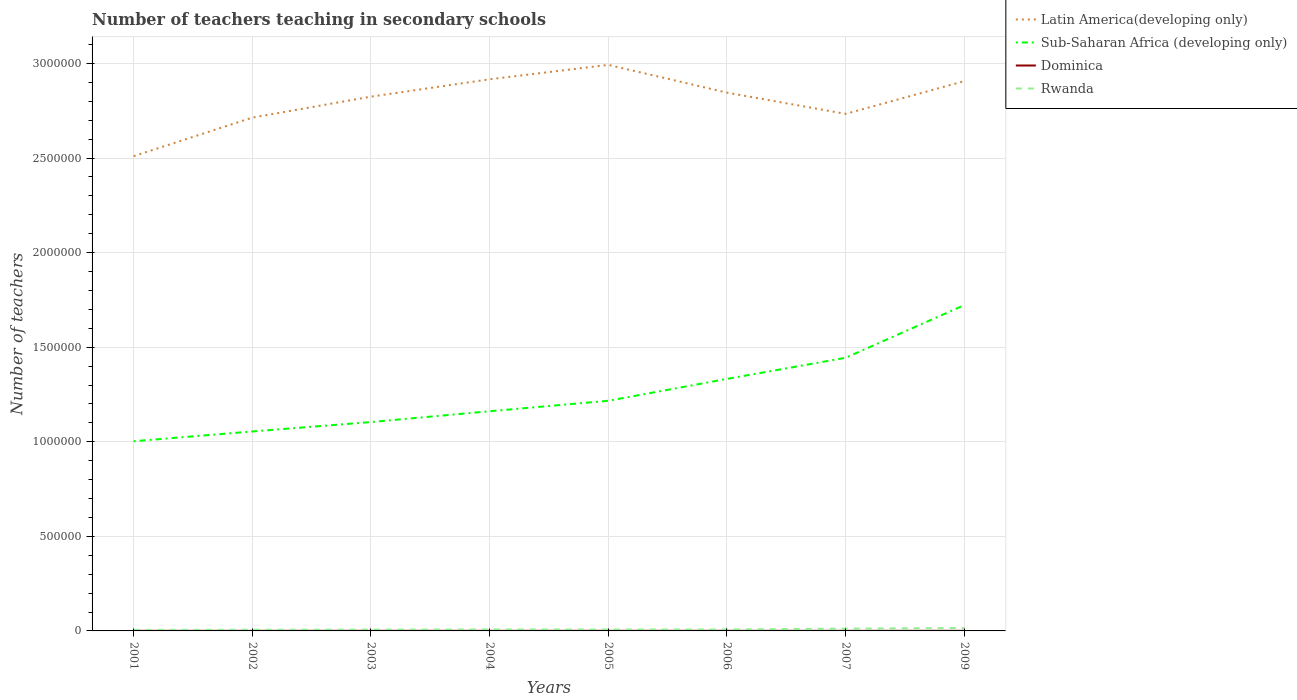How many different coloured lines are there?
Your response must be concise. 4. Does the line corresponding to Dominica intersect with the line corresponding to Latin America(developing only)?
Provide a succinct answer. No. Across all years, what is the maximum number of teachers teaching in secondary schools in Latin America(developing only)?
Your answer should be compact. 2.51e+06. What is the total number of teachers teaching in secondary schools in Rwanda in the graph?
Give a very brief answer. -760. What is the difference between the highest and the second highest number of teachers teaching in secondary schools in Rwanda?
Your response must be concise. 9876. Is the number of teachers teaching in secondary schools in Rwanda strictly greater than the number of teachers teaching in secondary schools in Dominica over the years?
Offer a very short reply. No. How many years are there in the graph?
Your answer should be very brief. 8. Where does the legend appear in the graph?
Your answer should be compact. Top right. How many legend labels are there?
Offer a very short reply. 4. How are the legend labels stacked?
Your response must be concise. Vertical. What is the title of the graph?
Ensure brevity in your answer.  Number of teachers teaching in secondary schools. Does "Macao" appear as one of the legend labels in the graph?
Make the answer very short. No. What is the label or title of the Y-axis?
Your response must be concise. Number of teachers. What is the Number of teachers of Latin America(developing only) in 2001?
Your answer should be very brief. 2.51e+06. What is the Number of teachers in Sub-Saharan Africa (developing only) in 2001?
Make the answer very short. 1.00e+06. What is the Number of teachers of Dominica in 2001?
Make the answer very short. 374. What is the Number of teachers of Rwanda in 2001?
Provide a succinct answer. 5453. What is the Number of teachers in Latin America(developing only) in 2002?
Keep it short and to the point. 2.71e+06. What is the Number of teachers in Sub-Saharan Africa (developing only) in 2002?
Your answer should be compact. 1.05e+06. What is the Number of teachers in Dominica in 2002?
Ensure brevity in your answer.  443. What is the Number of teachers of Rwanda in 2002?
Make the answer very short. 6329. What is the Number of teachers of Latin America(developing only) in 2003?
Your answer should be very brief. 2.82e+06. What is the Number of teachers in Sub-Saharan Africa (developing only) in 2003?
Your response must be concise. 1.10e+06. What is the Number of teachers in Dominica in 2003?
Make the answer very short. 460. What is the Number of teachers in Rwanda in 2003?
Ensure brevity in your answer.  7058. What is the Number of teachers in Latin America(developing only) in 2004?
Provide a succinct answer. 2.92e+06. What is the Number of teachers in Sub-Saharan Africa (developing only) in 2004?
Ensure brevity in your answer.  1.16e+06. What is the Number of teachers of Dominica in 2004?
Give a very brief answer. 445. What is the Number of teachers of Rwanda in 2004?
Ensure brevity in your answer.  7750. What is the Number of teachers of Latin America(developing only) in 2005?
Keep it short and to the point. 2.99e+06. What is the Number of teachers of Sub-Saharan Africa (developing only) in 2005?
Keep it short and to the point. 1.22e+06. What is the Number of teachers in Dominica in 2005?
Make the answer very short. 496. What is the Number of teachers in Rwanda in 2005?
Make the answer very short. 7610. What is the Number of teachers in Latin America(developing only) in 2006?
Your answer should be compact. 2.85e+06. What is the Number of teachers in Sub-Saharan Africa (developing only) in 2006?
Keep it short and to the point. 1.33e+06. What is the Number of teachers of Dominica in 2006?
Your response must be concise. 455. What is the Number of teachers of Rwanda in 2006?
Keep it short and to the point. 7818. What is the Number of teachers of Latin America(developing only) in 2007?
Ensure brevity in your answer.  2.73e+06. What is the Number of teachers in Sub-Saharan Africa (developing only) in 2007?
Ensure brevity in your answer.  1.44e+06. What is the Number of teachers of Dominica in 2007?
Provide a short and direct response. 469. What is the Number of teachers of Rwanda in 2007?
Provide a short and direct response. 1.21e+04. What is the Number of teachers in Latin America(developing only) in 2009?
Give a very brief answer. 2.91e+06. What is the Number of teachers in Sub-Saharan Africa (developing only) in 2009?
Your response must be concise. 1.72e+06. What is the Number of teachers of Dominica in 2009?
Offer a terse response. 524. What is the Number of teachers of Rwanda in 2009?
Ensure brevity in your answer.  1.53e+04. Across all years, what is the maximum Number of teachers in Latin America(developing only)?
Offer a terse response. 2.99e+06. Across all years, what is the maximum Number of teachers in Sub-Saharan Africa (developing only)?
Make the answer very short. 1.72e+06. Across all years, what is the maximum Number of teachers of Dominica?
Your answer should be compact. 524. Across all years, what is the maximum Number of teachers in Rwanda?
Keep it short and to the point. 1.53e+04. Across all years, what is the minimum Number of teachers of Latin America(developing only)?
Offer a very short reply. 2.51e+06. Across all years, what is the minimum Number of teachers of Sub-Saharan Africa (developing only)?
Keep it short and to the point. 1.00e+06. Across all years, what is the minimum Number of teachers in Dominica?
Offer a very short reply. 374. Across all years, what is the minimum Number of teachers in Rwanda?
Make the answer very short. 5453. What is the total Number of teachers of Latin America(developing only) in the graph?
Provide a short and direct response. 2.24e+07. What is the total Number of teachers of Sub-Saharan Africa (developing only) in the graph?
Give a very brief answer. 1.00e+07. What is the total Number of teachers in Dominica in the graph?
Your answer should be compact. 3666. What is the total Number of teachers in Rwanda in the graph?
Your answer should be very brief. 6.94e+04. What is the difference between the Number of teachers in Latin America(developing only) in 2001 and that in 2002?
Your response must be concise. -2.04e+05. What is the difference between the Number of teachers of Sub-Saharan Africa (developing only) in 2001 and that in 2002?
Your answer should be very brief. -5.16e+04. What is the difference between the Number of teachers of Dominica in 2001 and that in 2002?
Offer a very short reply. -69. What is the difference between the Number of teachers in Rwanda in 2001 and that in 2002?
Provide a succinct answer. -876. What is the difference between the Number of teachers of Latin America(developing only) in 2001 and that in 2003?
Provide a succinct answer. -3.15e+05. What is the difference between the Number of teachers in Sub-Saharan Africa (developing only) in 2001 and that in 2003?
Keep it short and to the point. -1.01e+05. What is the difference between the Number of teachers of Dominica in 2001 and that in 2003?
Make the answer very short. -86. What is the difference between the Number of teachers of Rwanda in 2001 and that in 2003?
Keep it short and to the point. -1605. What is the difference between the Number of teachers of Latin America(developing only) in 2001 and that in 2004?
Your answer should be compact. -4.06e+05. What is the difference between the Number of teachers of Sub-Saharan Africa (developing only) in 2001 and that in 2004?
Give a very brief answer. -1.59e+05. What is the difference between the Number of teachers in Dominica in 2001 and that in 2004?
Ensure brevity in your answer.  -71. What is the difference between the Number of teachers of Rwanda in 2001 and that in 2004?
Your answer should be very brief. -2297. What is the difference between the Number of teachers in Latin America(developing only) in 2001 and that in 2005?
Offer a very short reply. -4.83e+05. What is the difference between the Number of teachers of Sub-Saharan Africa (developing only) in 2001 and that in 2005?
Give a very brief answer. -2.14e+05. What is the difference between the Number of teachers in Dominica in 2001 and that in 2005?
Offer a very short reply. -122. What is the difference between the Number of teachers of Rwanda in 2001 and that in 2005?
Provide a short and direct response. -2157. What is the difference between the Number of teachers in Latin America(developing only) in 2001 and that in 2006?
Keep it short and to the point. -3.36e+05. What is the difference between the Number of teachers of Sub-Saharan Africa (developing only) in 2001 and that in 2006?
Offer a terse response. -3.30e+05. What is the difference between the Number of teachers of Dominica in 2001 and that in 2006?
Give a very brief answer. -81. What is the difference between the Number of teachers in Rwanda in 2001 and that in 2006?
Provide a succinct answer. -2365. What is the difference between the Number of teachers of Latin America(developing only) in 2001 and that in 2007?
Give a very brief answer. -2.24e+05. What is the difference between the Number of teachers of Sub-Saharan Africa (developing only) in 2001 and that in 2007?
Your answer should be compact. -4.41e+05. What is the difference between the Number of teachers of Dominica in 2001 and that in 2007?
Offer a terse response. -95. What is the difference between the Number of teachers in Rwanda in 2001 and that in 2007?
Ensure brevity in your answer.  -6650. What is the difference between the Number of teachers in Latin America(developing only) in 2001 and that in 2009?
Provide a short and direct response. -3.96e+05. What is the difference between the Number of teachers in Sub-Saharan Africa (developing only) in 2001 and that in 2009?
Provide a succinct answer. -7.20e+05. What is the difference between the Number of teachers of Dominica in 2001 and that in 2009?
Offer a very short reply. -150. What is the difference between the Number of teachers in Rwanda in 2001 and that in 2009?
Offer a very short reply. -9876. What is the difference between the Number of teachers of Latin America(developing only) in 2002 and that in 2003?
Your answer should be compact. -1.11e+05. What is the difference between the Number of teachers of Sub-Saharan Africa (developing only) in 2002 and that in 2003?
Offer a terse response. -4.98e+04. What is the difference between the Number of teachers of Dominica in 2002 and that in 2003?
Your answer should be compact. -17. What is the difference between the Number of teachers in Rwanda in 2002 and that in 2003?
Offer a very short reply. -729. What is the difference between the Number of teachers in Latin America(developing only) in 2002 and that in 2004?
Ensure brevity in your answer.  -2.03e+05. What is the difference between the Number of teachers of Sub-Saharan Africa (developing only) in 2002 and that in 2004?
Make the answer very short. -1.07e+05. What is the difference between the Number of teachers in Dominica in 2002 and that in 2004?
Offer a very short reply. -2. What is the difference between the Number of teachers in Rwanda in 2002 and that in 2004?
Offer a terse response. -1421. What is the difference between the Number of teachers in Latin America(developing only) in 2002 and that in 2005?
Ensure brevity in your answer.  -2.79e+05. What is the difference between the Number of teachers of Sub-Saharan Africa (developing only) in 2002 and that in 2005?
Your answer should be very brief. -1.62e+05. What is the difference between the Number of teachers in Dominica in 2002 and that in 2005?
Your answer should be very brief. -53. What is the difference between the Number of teachers in Rwanda in 2002 and that in 2005?
Give a very brief answer. -1281. What is the difference between the Number of teachers in Latin America(developing only) in 2002 and that in 2006?
Offer a very short reply. -1.32e+05. What is the difference between the Number of teachers in Sub-Saharan Africa (developing only) in 2002 and that in 2006?
Provide a succinct answer. -2.78e+05. What is the difference between the Number of teachers in Rwanda in 2002 and that in 2006?
Your response must be concise. -1489. What is the difference between the Number of teachers in Latin America(developing only) in 2002 and that in 2007?
Provide a succinct answer. -1.98e+04. What is the difference between the Number of teachers in Sub-Saharan Africa (developing only) in 2002 and that in 2007?
Offer a very short reply. -3.90e+05. What is the difference between the Number of teachers of Dominica in 2002 and that in 2007?
Offer a very short reply. -26. What is the difference between the Number of teachers of Rwanda in 2002 and that in 2007?
Your answer should be very brief. -5774. What is the difference between the Number of teachers of Latin America(developing only) in 2002 and that in 2009?
Provide a succinct answer. -1.93e+05. What is the difference between the Number of teachers of Sub-Saharan Africa (developing only) in 2002 and that in 2009?
Make the answer very short. -6.68e+05. What is the difference between the Number of teachers in Dominica in 2002 and that in 2009?
Keep it short and to the point. -81. What is the difference between the Number of teachers in Rwanda in 2002 and that in 2009?
Keep it short and to the point. -9000. What is the difference between the Number of teachers of Latin America(developing only) in 2003 and that in 2004?
Your response must be concise. -9.17e+04. What is the difference between the Number of teachers in Sub-Saharan Africa (developing only) in 2003 and that in 2004?
Your answer should be compact. -5.71e+04. What is the difference between the Number of teachers in Dominica in 2003 and that in 2004?
Provide a succinct answer. 15. What is the difference between the Number of teachers in Rwanda in 2003 and that in 2004?
Give a very brief answer. -692. What is the difference between the Number of teachers in Latin America(developing only) in 2003 and that in 2005?
Your response must be concise. -1.68e+05. What is the difference between the Number of teachers of Sub-Saharan Africa (developing only) in 2003 and that in 2005?
Offer a terse response. -1.12e+05. What is the difference between the Number of teachers in Dominica in 2003 and that in 2005?
Your response must be concise. -36. What is the difference between the Number of teachers of Rwanda in 2003 and that in 2005?
Provide a short and direct response. -552. What is the difference between the Number of teachers of Latin America(developing only) in 2003 and that in 2006?
Your answer should be compact. -2.10e+04. What is the difference between the Number of teachers of Sub-Saharan Africa (developing only) in 2003 and that in 2006?
Offer a very short reply. -2.28e+05. What is the difference between the Number of teachers of Dominica in 2003 and that in 2006?
Make the answer very short. 5. What is the difference between the Number of teachers of Rwanda in 2003 and that in 2006?
Your answer should be very brief. -760. What is the difference between the Number of teachers of Latin America(developing only) in 2003 and that in 2007?
Your response must be concise. 9.12e+04. What is the difference between the Number of teachers in Sub-Saharan Africa (developing only) in 2003 and that in 2007?
Provide a succinct answer. -3.40e+05. What is the difference between the Number of teachers of Rwanda in 2003 and that in 2007?
Keep it short and to the point. -5045. What is the difference between the Number of teachers of Latin America(developing only) in 2003 and that in 2009?
Ensure brevity in your answer.  -8.18e+04. What is the difference between the Number of teachers of Sub-Saharan Africa (developing only) in 2003 and that in 2009?
Keep it short and to the point. -6.18e+05. What is the difference between the Number of teachers of Dominica in 2003 and that in 2009?
Your response must be concise. -64. What is the difference between the Number of teachers of Rwanda in 2003 and that in 2009?
Your response must be concise. -8271. What is the difference between the Number of teachers of Latin America(developing only) in 2004 and that in 2005?
Make the answer very short. -7.62e+04. What is the difference between the Number of teachers of Sub-Saharan Africa (developing only) in 2004 and that in 2005?
Offer a terse response. -5.53e+04. What is the difference between the Number of teachers of Dominica in 2004 and that in 2005?
Make the answer very short. -51. What is the difference between the Number of teachers of Rwanda in 2004 and that in 2005?
Ensure brevity in your answer.  140. What is the difference between the Number of teachers in Latin America(developing only) in 2004 and that in 2006?
Your answer should be compact. 7.07e+04. What is the difference between the Number of teachers in Sub-Saharan Africa (developing only) in 2004 and that in 2006?
Your answer should be compact. -1.71e+05. What is the difference between the Number of teachers in Rwanda in 2004 and that in 2006?
Provide a succinct answer. -68. What is the difference between the Number of teachers in Latin America(developing only) in 2004 and that in 2007?
Offer a terse response. 1.83e+05. What is the difference between the Number of teachers in Sub-Saharan Africa (developing only) in 2004 and that in 2007?
Offer a very short reply. -2.83e+05. What is the difference between the Number of teachers in Rwanda in 2004 and that in 2007?
Your answer should be compact. -4353. What is the difference between the Number of teachers of Latin America(developing only) in 2004 and that in 2009?
Your answer should be compact. 9897.5. What is the difference between the Number of teachers of Sub-Saharan Africa (developing only) in 2004 and that in 2009?
Make the answer very short. -5.61e+05. What is the difference between the Number of teachers in Dominica in 2004 and that in 2009?
Keep it short and to the point. -79. What is the difference between the Number of teachers in Rwanda in 2004 and that in 2009?
Ensure brevity in your answer.  -7579. What is the difference between the Number of teachers in Latin America(developing only) in 2005 and that in 2006?
Your response must be concise. 1.47e+05. What is the difference between the Number of teachers of Sub-Saharan Africa (developing only) in 2005 and that in 2006?
Your answer should be compact. -1.16e+05. What is the difference between the Number of teachers in Dominica in 2005 and that in 2006?
Offer a very short reply. 41. What is the difference between the Number of teachers in Rwanda in 2005 and that in 2006?
Provide a succinct answer. -208. What is the difference between the Number of teachers of Latin America(developing only) in 2005 and that in 2007?
Give a very brief answer. 2.59e+05. What is the difference between the Number of teachers in Sub-Saharan Africa (developing only) in 2005 and that in 2007?
Give a very brief answer. -2.27e+05. What is the difference between the Number of teachers of Dominica in 2005 and that in 2007?
Keep it short and to the point. 27. What is the difference between the Number of teachers of Rwanda in 2005 and that in 2007?
Provide a succinct answer. -4493. What is the difference between the Number of teachers in Latin America(developing only) in 2005 and that in 2009?
Your answer should be compact. 8.61e+04. What is the difference between the Number of teachers of Sub-Saharan Africa (developing only) in 2005 and that in 2009?
Your answer should be very brief. -5.06e+05. What is the difference between the Number of teachers in Dominica in 2005 and that in 2009?
Provide a succinct answer. -28. What is the difference between the Number of teachers in Rwanda in 2005 and that in 2009?
Offer a very short reply. -7719. What is the difference between the Number of teachers in Latin America(developing only) in 2006 and that in 2007?
Your answer should be very brief. 1.12e+05. What is the difference between the Number of teachers in Sub-Saharan Africa (developing only) in 2006 and that in 2007?
Offer a terse response. -1.12e+05. What is the difference between the Number of teachers in Dominica in 2006 and that in 2007?
Offer a terse response. -14. What is the difference between the Number of teachers of Rwanda in 2006 and that in 2007?
Provide a short and direct response. -4285. What is the difference between the Number of teachers of Latin America(developing only) in 2006 and that in 2009?
Your answer should be very brief. -6.08e+04. What is the difference between the Number of teachers in Sub-Saharan Africa (developing only) in 2006 and that in 2009?
Your response must be concise. -3.90e+05. What is the difference between the Number of teachers in Dominica in 2006 and that in 2009?
Provide a short and direct response. -69. What is the difference between the Number of teachers of Rwanda in 2006 and that in 2009?
Make the answer very short. -7511. What is the difference between the Number of teachers of Latin America(developing only) in 2007 and that in 2009?
Your answer should be compact. -1.73e+05. What is the difference between the Number of teachers in Sub-Saharan Africa (developing only) in 2007 and that in 2009?
Your answer should be compact. -2.78e+05. What is the difference between the Number of teachers in Dominica in 2007 and that in 2009?
Provide a short and direct response. -55. What is the difference between the Number of teachers of Rwanda in 2007 and that in 2009?
Offer a very short reply. -3226. What is the difference between the Number of teachers in Latin America(developing only) in 2001 and the Number of teachers in Sub-Saharan Africa (developing only) in 2002?
Your answer should be compact. 1.46e+06. What is the difference between the Number of teachers of Latin America(developing only) in 2001 and the Number of teachers of Dominica in 2002?
Provide a short and direct response. 2.51e+06. What is the difference between the Number of teachers of Latin America(developing only) in 2001 and the Number of teachers of Rwanda in 2002?
Provide a short and direct response. 2.50e+06. What is the difference between the Number of teachers in Sub-Saharan Africa (developing only) in 2001 and the Number of teachers in Dominica in 2002?
Provide a short and direct response. 1.00e+06. What is the difference between the Number of teachers in Sub-Saharan Africa (developing only) in 2001 and the Number of teachers in Rwanda in 2002?
Keep it short and to the point. 9.97e+05. What is the difference between the Number of teachers of Dominica in 2001 and the Number of teachers of Rwanda in 2002?
Make the answer very short. -5955. What is the difference between the Number of teachers in Latin America(developing only) in 2001 and the Number of teachers in Sub-Saharan Africa (developing only) in 2003?
Make the answer very short. 1.41e+06. What is the difference between the Number of teachers of Latin America(developing only) in 2001 and the Number of teachers of Dominica in 2003?
Your response must be concise. 2.51e+06. What is the difference between the Number of teachers in Latin America(developing only) in 2001 and the Number of teachers in Rwanda in 2003?
Your answer should be compact. 2.50e+06. What is the difference between the Number of teachers of Sub-Saharan Africa (developing only) in 2001 and the Number of teachers of Dominica in 2003?
Ensure brevity in your answer.  1.00e+06. What is the difference between the Number of teachers of Sub-Saharan Africa (developing only) in 2001 and the Number of teachers of Rwanda in 2003?
Offer a very short reply. 9.96e+05. What is the difference between the Number of teachers in Dominica in 2001 and the Number of teachers in Rwanda in 2003?
Offer a very short reply. -6684. What is the difference between the Number of teachers of Latin America(developing only) in 2001 and the Number of teachers of Sub-Saharan Africa (developing only) in 2004?
Make the answer very short. 1.35e+06. What is the difference between the Number of teachers of Latin America(developing only) in 2001 and the Number of teachers of Dominica in 2004?
Offer a very short reply. 2.51e+06. What is the difference between the Number of teachers of Latin America(developing only) in 2001 and the Number of teachers of Rwanda in 2004?
Make the answer very short. 2.50e+06. What is the difference between the Number of teachers in Sub-Saharan Africa (developing only) in 2001 and the Number of teachers in Dominica in 2004?
Keep it short and to the point. 1.00e+06. What is the difference between the Number of teachers of Sub-Saharan Africa (developing only) in 2001 and the Number of teachers of Rwanda in 2004?
Ensure brevity in your answer.  9.95e+05. What is the difference between the Number of teachers of Dominica in 2001 and the Number of teachers of Rwanda in 2004?
Ensure brevity in your answer.  -7376. What is the difference between the Number of teachers in Latin America(developing only) in 2001 and the Number of teachers in Sub-Saharan Africa (developing only) in 2005?
Your answer should be very brief. 1.29e+06. What is the difference between the Number of teachers in Latin America(developing only) in 2001 and the Number of teachers in Dominica in 2005?
Your answer should be very brief. 2.51e+06. What is the difference between the Number of teachers of Latin America(developing only) in 2001 and the Number of teachers of Rwanda in 2005?
Offer a very short reply. 2.50e+06. What is the difference between the Number of teachers of Sub-Saharan Africa (developing only) in 2001 and the Number of teachers of Dominica in 2005?
Provide a short and direct response. 1.00e+06. What is the difference between the Number of teachers in Sub-Saharan Africa (developing only) in 2001 and the Number of teachers in Rwanda in 2005?
Offer a terse response. 9.95e+05. What is the difference between the Number of teachers of Dominica in 2001 and the Number of teachers of Rwanda in 2005?
Give a very brief answer. -7236. What is the difference between the Number of teachers in Latin America(developing only) in 2001 and the Number of teachers in Sub-Saharan Africa (developing only) in 2006?
Keep it short and to the point. 1.18e+06. What is the difference between the Number of teachers in Latin America(developing only) in 2001 and the Number of teachers in Dominica in 2006?
Offer a very short reply. 2.51e+06. What is the difference between the Number of teachers of Latin America(developing only) in 2001 and the Number of teachers of Rwanda in 2006?
Your response must be concise. 2.50e+06. What is the difference between the Number of teachers in Sub-Saharan Africa (developing only) in 2001 and the Number of teachers in Dominica in 2006?
Ensure brevity in your answer.  1.00e+06. What is the difference between the Number of teachers in Sub-Saharan Africa (developing only) in 2001 and the Number of teachers in Rwanda in 2006?
Keep it short and to the point. 9.95e+05. What is the difference between the Number of teachers in Dominica in 2001 and the Number of teachers in Rwanda in 2006?
Provide a succinct answer. -7444. What is the difference between the Number of teachers of Latin America(developing only) in 2001 and the Number of teachers of Sub-Saharan Africa (developing only) in 2007?
Offer a very short reply. 1.07e+06. What is the difference between the Number of teachers of Latin America(developing only) in 2001 and the Number of teachers of Dominica in 2007?
Keep it short and to the point. 2.51e+06. What is the difference between the Number of teachers of Latin America(developing only) in 2001 and the Number of teachers of Rwanda in 2007?
Offer a very short reply. 2.50e+06. What is the difference between the Number of teachers in Sub-Saharan Africa (developing only) in 2001 and the Number of teachers in Dominica in 2007?
Give a very brief answer. 1.00e+06. What is the difference between the Number of teachers in Sub-Saharan Africa (developing only) in 2001 and the Number of teachers in Rwanda in 2007?
Provide a short and direct response. 9.91e+05. What is the difference between the Number of teachers in Dominica in 2001 and the Number of teachers in Rwanda in 2007?
Offer a terse response. -1.17e+04. What is the difference between the Number of teachers of Latin America(developing only) in 2001 and the Number of teachers of Sub-Saharan Africa (developing only) in 2009?
Offer a terse response. 7.87e+05. What is the difference between the Number of teachers in Latin America(developing only) in 2001 and the Number of teachers in Dominica in 2009?
Offer a very short reply. 2.51e+06. What is the difference between the Number of teachers in Latin America(developing only) in 2001 and the Number of teachers in Rwanda in 2009?
Your answer should be very brief. 2.49e+06. What is the difference between the Number of teachers of Sub-Saharan Africa (developing only) in 2001 and the Number of teachers of Dominica in 2009?
Offer a very short reply. 1.00e+06. What is the difference between the Number of teachers in Sub-Saharan Africa (developing only) in 2001 and the Number of teachers in Rwanda in 2009?
Your response must be concise. 9.88e+05. What is the difference between the Number of teachers of Dominica in 2001 and the Number of teachers of Rwanda in 2009?
Ensure brevity in your answer.  -1.50e+04. What is the difference between the Number of teachers in Latin America(developing only) in 2002 and the Number of teachers in Sub-Saharan Africa (developing only) in 2003?
Your response must be concise. 1.61e+06. What is the difference between the Number of teachers of Latin America(developing only) in 2002 and the Number of teachers of Dominica in 2003?
Your answer should be compact. 2.71e+06. What is the difference between the Number of teachers in Latin America(developing only) in 2002 and the Number of teachers in Rwanda in 2003?
Provide a succinct answer. 2.71e+06. What is the difference between the Number of teachers of Sub-Saharan Africa (developing only) in 2002 and the Number of teachers of Dominica in 2003?
Provide a short and direct response. 1.05e+06. What is the difference between the Number of teachers of Sub-Saharan Africa (developing only) in 2002 and the Number of teachers of Rwanda in 2003?
Your answer should be compact. 1.05e+06. What is the difference between the Number of teachers in Dominica in 2002 and the Number of teachers in Rwanda in 2003?
Offer a terse response. -6615. What is the difference between the Number of teachers of Latin America(developing only) in 2002 and the Number of teachers of Sub-Saharan Africa (developing only) in 2004?
Keep it short and to the point. 1.55e+06. What is the difference between the Number of teachers in Latin America(developing only) in 2002 and the Number of teachers in Dominica in 2004?
Give a very brief answer. 2.71e+06. What is the difference between the Number of teachers of Latin America(developing only) in 2002 and the Number of teachers of Rwanda in 2004?
Offer a terse response. 2.71e+06. What is the difference between the Number of teachers in Sub-Saharan Africa (developing only) in 2002 and the Number of teachers in Dominica in 2004?
Give a very brief answer. 1.05e+06. What is the difference between the Number of teachers in Sub-Saharan Africa (developing only) in 2002 and the Number of teachers in Rwanda in 2004?
Your answer should be very brief. 1.05e+06. What is the difference between the Number of teachers of Dominica in 2002 and the Number of teachers of Rwanda in 2004?
Your response must be concise. -7307. What is the difference between the Number of teachers of Latin America(developing only) in 2002 and the Number of teachers of Sub-Saharan Africa (developing only) in 2005?
Your answer should be compact. 1.50e+06. What is the difference between the Number of teachers in Latin America(developing only) in 2002 and the Number of teachers in Dominica in 2005?
Give a very brief answer. 2.71e+06. What is the difference between the Number of teachers in Latin America(developing only) in 2002 and the Number of teachers in Rwanda in 2005?
Keep it short and to the point. 2.71e+06. What is the difference between the Number of teachers in Sub-Saharan Africa (developing only) in 2002 and the Number of teachers in Dominica in 2005?
Keep it short and to the point. 1.05e+06. What is the difference between the Number of teachers of Sub-Saharan Africa (developing only) in 2002 and the Number of teachers of Rwanda in 2005?
Ensure brevity in your answer.  1.05e+06. What is the difference between the Number of teachers in Dominica in 2002 and the Number of teachers in Rwanda in 2005?
Offer a very short reply. -7167. What is the difference between the Number of teachers of Latin America(developing only) in 2002 and the Number of teachers of Sub-Saharan Africa (developing only) in 2006?
Provide a short and direct response. 1.38e+06. What is the difference between the Number of teachers in Latin America(developing only) in 2002 and the Number of teachers in Dominica in 2006?
Offer a terse response. 2.71e+06. What is the difference between the Number of teachers in Latin America(developing only) in 2002 and the Number of teachers in Rwanda in 2006?
Give a very brief answer. 2.71e+06. What is the difference between the Number of teachers in Sub-Saharan Africa (developing only) in 2002 and the Number of teachers in Dominica in 2006?
Offer a very short reply. 1.05e+06. What is the difference between the Number of teachers of Sub-Saharan Africa (developing only) in 2002 and the Number of teachers of Rwanda in 2006?
Offer a very short reply. 1.05e+06. What is the difference between the Number of teachers of Dominica in 2002 and the Number of teachers of Rwanda in 2006?
Offer a terse response. -7375. What is the difference between the Number of teachers of Latin America(developing only) in 2002 and the Number of teachers of Sub-Saharan Africa (developing only) in 2007?
Give a very brief answer. 1.27e+06. What is the difference between the Number of teachers of Latin America(developing only) in 2002 and the Number of teachers of Dominica in 2007?
Keep it short and to the point. 2.71e+06. What is the difference between the Number of teachers of Latin America(developing only) in 2002 and the Number of teachers of Rwanda in 2007?
Provide a short and direct response. 2.70e+06. What is the difference between the Number of teachers of Sub-Saharan Africa (developing only) in 2002 and the Number of teachers of Dominica in 2007?
Keep it short and to the point. 1.05e+06. What is the difference between the Number of teachers in Sub-Saharan Africa (developing only) in 2002 and the Number of teachers in Rwanda in 2007?
Offer a terse response. 1.04e+06. What is the difference between the Number of teachers in Dominica in 2002 and the Number of teachers in Rwanda in 2007?
Your answer should be very brief. -1.17e+04. What is the difference between the Number of teachers of Latin America(developing only) in 2002 and the Number of teachers of Sub-Saharan Africa (developing only) in 2009?
Your answer should be very brief. 9.91e+05. What is the difference between the Number of teachers in Latin America(developing only) in 2002 and the Number of teachers in Dominica in 2009?
Make the answer very short. 2.71e+06. What is the difference between the Number of teachers of Latin America(developing only) in 2002 and the Number of teachers of Rwanda in 2009?
Ensure brevity in your answer.  2.70e+06. What is the difference between the Number of teachers of Sub-Saharan Africa (developing only) in 2002 and the Number of teachers of Dominica in 2009?
Give a very brief answer. 1.05e+06. What is the difference between the Number of teachers of Sub-Saharan Africa (developing only) in 2002 and the Number of teachers of Rwanda in 2009?
Keep it short and to the point. 1.04e+06. What is the difference between the Number of teachers in Dominica in 2002 and the Number of teachers in Rwanda in 2009?
Your response must be concise. -1.49e+04. What is the difference between the Number of teachers in Latin America(developing only) in 2003 and the Number of teachers in Sub-Saharan Africa (developing only) in 2004?
Offer a very short reply. 1.66e+06. What is the difference between the Number of teachers in Latin America(developing only) in 2003 and the Number of teachers in Dominica in 2004?
Provide a short and direct response. 2.82e+06. What is the difference between the Number of teachers in Latin America(developing only) in 2003 and the Number of teachers in Rwanda in 2004?
Your answer should be compact. 2.82e+06. What is the difference between the Number of teachers of Sub-Saharan Africa (developing only) in 2003 and the Number of teachers of Dominica in 2004?
Provide a short and direct response. 1.10e+06. What is the difference between the Number of teachers in Sub-Saharan Africa (developing only) in 2003 and the Number of teachers in Rwanda in 2004?
Offer a very short reply. 1.10e+06. What is the difference between the Number of teachers of Dominica in 2003 and the Number of teachers of Rwanda in 2004?
Keep it short and to the point. -7290. What is the difference between the Number of teachers of Latin America(developing only) in 2003 and the Number of teachers of Sub-Saharan Africa (developing only) in 2005?
Make the answer very short. 1.61e+06. What is the difference between the Number of teachers of Latin America(developing only) in 2003 and the Number of teachers of Dominica in 2005?
Provide a short and direct response. 2.82e+06. What is the difference between the Number of teachers of Latin America(developing only) in 2003 and the Number of teachers of Rwanda in 2005?
Give a very brief answer. 2.82e+06. What is the difference between the Number of teachers in Sub-Saharan Africa (developing only) in 2003 and the Number of teachers in Dominica in 2005?
Keep it short and to the point. 1.10e+06. What is the difference between the Number of teachers of Sub-Saharan Africa (developing only) in 2003 and the Number of teachers of Rwanda in 2005?
Your answer should be compact. 1.10e+06. What is the difference between the Number of teachers of Dominica in 2003 and the Number of teachers of Rwanda in 2005?
Make the answer very short. -7150. What is the difference between the Number of teachers in Latin America(developing only) in 2003 and the Number of teachers in Sub-Saharan Africa (developing only) in 2006?
Offer a very short reply. 1.49e+06. What is the difference between the Number of teachers in Latin America(developing only) in 2003 and the Number of teachers in Dominica in 2006?
Your answer should be compact. 2.82e+06. What is the difference between the Number of teachers in Latin America(developing only) in 2003 and the Number of teachers in Rwanda in 2006?
Your answer should be compact. 2.82e+06. What is the difference between the Number of teachers in Sub-Saharan Africa (developing only) in 2003 and the Number of teachers in Dominica in 2006?
Ensure brevity in your answer.  1.10e+06. What is the difference between the Number of teachers of Sub-Saharan Africa (developing only) in 2003 and the Number of teachers of Rwanda in 2006?
Provide a succinct answer. 1.10e+06. What is the difference between the Number of teachers in Dominica in 2003 and the Number of teachers in Rwanda in 2006?
Ensure brevity in your answer.  -7358. What is the difference between the Number of teachers of Latin America(developing only) in 2003 and the Number of teachers of Sub-Saharan Africa (developing only) in 2007?
Provide a short and direct response. 1.38e+06. What is the difference between the Number of teachers of Latin America(developing only) in 2003 and the Number of teachers of Dominica in 2007?
Provide a short and direct response. 2.82e+06. What is the difference between the Number of teachers of Latin America(developing only) in 2003 and the Number of teachers of Rwanda in 2007?
Your answer should be very brief. 2.81e+06. What is the difference between the Number of teachers in Sub-Saharan Africa (developing only) in 2003 and the Number of teachers in Dominica in 2007?
Make the answer very short. 1.10e+06. What is the difference between the Number of teachers of Sub-Saharan Africa (developing only) in 2003 and the Number of teachers of Rwanda in 2007?
Your answer should be very brief. 1.09e+06. What is the difference between the Number of teachers in Dominica in 2003 and the Number of teachers in Rwanda in 2007?
Offer a terse response. -1.16e+04. What is the difference between the Number of teachers of Latin America(developing only) in 2003 and the Number of teachers of Sub-Saharan Africa (developing only) in 2009?
Your answer should be very brief. 1.10e+06. What is the difference between the Number of teachers of Latin America(developing only) in 2003 and the Number of teachers of Dominica in 2009?
Make the answer very short. 2.82e+06. What is the difference between the Number of teachers in Latin America(developing only) in 2003 and the Number of teachers in Rwanda in 2009?
Provide a short and direct response. 2.81e+06. What is the difference between the Number of teachers in Sub-Saharan Africa (developing only) in 2003 and the Number of teachers in Dominica in 2009?
Keep it short and to the point. 1.10e+06. What is the difference between the Number of teachers in Sub-Saharan Africa (developing only) in 2003 and the Number of teachers in Rwanda in 2009?
Give a very brief answer. 1.09e+06. What is the difference between the Number of teachers of Dominica in 2003 and the Number of teachers of Rwanda in 2009?
Your answer should be very brief. -1.49e+04. What is the difference between the Number of teachers in Latin America(developing only) in 2004 and the Number of teachers in Sub-Saharan Africa (developing only) in 2005?
Provide a succinct answer. 1.70e+06. What is the difference between the Number of teachers in Latin America(developing only) in 2004 and the Number of teachers in Dominica in 2005?
Provide a short and direct response. 2.92e+06. What is the difference between the Number of teachers of Latin America(developing only) in 2004 and the Number of teachers of Rwanda in 2005?
Give a very brief answer. 2.91e+06. What is the difference between the Number of teachers in Sub-Saharan Africa (developing only) in 2004 and the Number of teachers in Dominica in 2005?
Ensure brevity in your answer.  1.16e+06. What is the difference between the Number of teachers in Sub-Saharan Africa (developing only) in 2004 and the Number of teachers in Rwanda in 2005?
Make the answer very short. 1.15e+06. What is the difference between the Number of teachers of Dominica in 2004 and the Number of teachers of Rwanda in 2005?
Your answer should be very brief. -7165. What is the difference between the Number of teachers of Latin America(developing only) in 2004 and the Number of teachers of Sub-Saharan Africa (developing only) in 2006?
Ensure brevity in your answer.  1.58e+06. What is the difference between the Number of teachers of Latin America(developing only) in 2004 and the Number of teachers of Dominica in 2006?
Give a very brief answer. 2.92e+06. What is the difference between the Number of teachers in Latin America(developing only) in 2004 and the Number of teachers in Rwanda in 2006?
Your answer should be compact. 2.91e+06. What is the difference between the Number of teachers of Sub-Saharan Africa (developing only) in 2004 and the Number of teachers of Dominica in 2006?
Offer a very short reply. 1.16e+06. What is the difference between the Number of teachers in Sub-Saharan Africa (developing only) in 2004 and the Number of teachers in Rwanda in 2006?
Your response must be concise. 1.15e+06. What is the difference between the Number of teachers of Dominica in 2004 and the Number of teachers of Rwanda in 2006?
Offer a terse response. -7373. What is the difference between the Number of teachers in Latin America(developing only) in 2004 and the Number of teachers in Sub-Saharan Africa (developing only) in 2007?
Your answer should be compact. 1.47e+06. What is the difference between the Number of teachers in Latin America(developing only) in 2004 and the Number of teachers in Dominica in 2007?
Provide a short and direct response. 2.92e+06. What is the difference between the Number of teachers of Latin America(developing only) in 2004 and the Number of teachers of Rwanda in 2007?
Your answer should be very brief. 2.90e+06. What is the difference between the Number of teachers in Sub-Saharan Africa (developing only) in 2004 and the Number of teachers in Dominica in 2007?
Ensure brevity in your answer.  1.16e+06. What is the difference between the Number of teachers of Sub-Saharan Africa (developing only) in 2004 and the Number of teachers of Rwanda in 2007?
Ensure brevity in your answer.  1.15e+06. What is the difference between the Number of teachers in Dominica in 2004 and the Number of teachers in Rwanda in 2007?
Keep it short and to the point. -1.17e+04. What is the difference between the Number of teachers in Latin America(developing only) in 2004 and the Number of teachers in Sub-Saharan Africa (developing only) in 2009?
Your response must be concise. 1.19e+06. What is the difference between the Number of teachers in Latin America(developing only) in 2004 and the Number of teachers in Dominica in 2009?
Give a very brief answer. 2.92e+06. What is the difference between the Number of teachers in Latin America(developing only) in 2004 and the Number of teachers in Rwanda in 2009?
Provide a short and direct response. 2.90e+06. What is the difference between the Number of teachers of Sub-Saharan Africa (developing only) in 2004 and the Number of teachers of Dominica in 2009?
Make the answer very short. 1.16e+06. What is the difference between the Number of teachers of Sub-Saharan Africa (developing only) in 2004 and the Number of teachers of Rwanda in 2009?
Give a very brief answer. 1.15e+06. What is the difference between the Number of teachers of Dominica in 2004 and the Number of teachers of Rwanda in 2009?
Your response must be concise. -1.49e+04. What is the difference between the Number of teachers of Latin America(developing only) in 2005 and the Number of teachers of Sub-Saharan Africa (developing only) in 2006?
Your answer should be compact. 1.66e+06. What is the difference between the Number of teachers of Latin America(developing only) in 2005 and the Number of teachers of Dominica in 2006?
Provide a short and direct response. 2.99e+06. What is the difference between the Number of teachers in Latin America(developing only) in 2005 and the Number of teachers in Rwanda in 2006?
Provide a short and direct response. 2.98e+06. What is the difference between the Number of teachers in Sub-Saharan Africa (developing only) in 2005 and the Number of teachers in Dominica in 2006?
Provide a succinct answer. 1.22e+06. What is the difference between the Number of teachers in Sub-Saharan Africa (developing only) in 2005 and the Number of teachers in Rwanda in 2006?
Your answer should be very brief. 1.21e+06. What is the difference between the Number of teachers of Dominica in 2005 and the Number of teachers of Rwanda in 2006?
Your answer should be very brief. -7322. What is the difference between the Number of teachers of Latin America(developing only) in 2005 and the Number of teachers of Sub-Saharan Africa (developing only) in 2007?
Provide a short and direct response. 1.55e+06. What is the difference between the Number of teachers of Latin America(developing only) in 2005 and the Number of teachers of Dominica in 2007?
Offer a very short reply. 2.99e+06. What is the difference between the Number of teachers in Latin America(developing only) in 2005 and the Number of teachers in Rwanda in 2007?
Provide a short and direct response. 2.98e+06. What is the difference between the Number of teachers of Sub-Saharan Africa (developing only) in 2005 and the Number of teachers of Dominica in 2007?
Make the answer very short. 1.22e+06. What is the difference between the Number of teachers in Sub-Saharan Africa (developing only) in 2005 and the Number of teachers in Rwanda in 2007?
Ensure brevity in your answer.  1.20e+06. What is the difference between the Number of teachers of Dominica in 2005 and the Number of teachers of Rwanda in 2007?
Give a very brief answer. -1.16e+04. What is the difference between the Number of teachers of Latin America(developing only) in 2005 and the Number of teachers of Sub-Saharan Africa (developing only) in 2009?
Ensure brevity in your answer.  1.27e+06. What is the difference between the Number of teachers in Latin America(developing only) in 2005 and the Number of teachers in Dominica in 2009?
Ensure brevity in your answer.  2.99e+06. What is the difference between the Number of teachers of Latin America(developing only) in 2005 and the Number of teachers of Rwanda in 2009?
Offer a very short reply. 2.98e+06. What is the difference between the Number of teachers in Sub-Saharan Africa (developing only) in 2005 and the Number of teachers in Dominica in 2009?
Give a very brief answer. 1.22e+06. What is the difference between the Number of teachers in Sub-Saharan Africa (developing only) in 2005 and the Number of teachers in Rwanda in 2009?
Keep it short and to the point. 1.20e+06. What is the difference between the Number of teachers in Dominica in 2005 and the Number of teachers in Rwanda in 2009?
Ensure brevity in your answer.  -1.48e+04. What is the difference between the Number of teachers in Latin America(developing only) in 2006 and the Number of teachers in Sub-Saharan Africa (developing only) in 2007?
Make the answer very short. 1.40e+06. What is the difference between the Number of teachers in Latin America(developing only) in 2006 and the Number of teachers in Dominica in 2007?
Offer a very short reply. 2.85e+06. What is the difference between the Number of teachers of Latin America(developing only) in 2006 and the Number of teachers of Rwanda in 2007?
Provide a short and direct response. 2.83e+06. What is the difference between the Number of teachers in Sub-Saharan Africa (developing only) in 2006 and the Number of teachers in Dominica in 2007?
Provide a succinct answer. 1.33e+06. What is the difference between the Number of teachers of Sub-Saharan Africa (developing only) in 2006 and the Number of teachers of Rwanda in 2007?
Offer a very short reply. 1.32e+06. What is the difference between the Number of teachers of Dominica in 2006 and the Number of teachers of Rwanda in 2007?
Provide a succinct answer. -1.16e+04. What is the difference between the Number of teachers in Latin America(developing only) in 2006 and the Number of teachers in Sub-Saharan Africa (developing only) in 2009?
Offer a terse response. 1.12e+06. What is the difference between the Number of teachers in Latin America(developing only) in 2006 and the Number of teachers in Dominica in 2009?
Give a very brief answer. 2.85e+06. What is the difference between the Number of teachers of Latin America(developing only) in 2006 and the Number of teachers of Rwanda in 2009?
Your answer should be compact. 2.83e+06. What is the difference between the Number of teachers in Sub-Saharan Africa (developing only) in 2006 and the Number of teachers in Dominica in 2009?
Your answer should be compact. 1.33e+06. What is the difference between the Number of teachers of Sub-Saharan Africa (developing only) in 2006 and the Number of teachers of Rwanda in 2009?
Offer a very short reply. 1.32e+06. What is the difference between the Number of teachers of Dominica in 2006 and the Number of teachers of Rwanda in 2009?
Make the answer very short. -1.49e+04. What is the difference between the Number of teachers of Latin America(developing only) in 2007 and the Number of teachers of Sub-Saharan Africa (developing only) in 2009?
Offer a very short reply. 1.01e+06. What is the difference between the Number of teachers of Latin America(developing only) in 2007 and the Number of teachers of Dominica in 2009?
Provide a succinct answer. 2.73e+06. What is the difference between the Number of teachers of Latin America(developing only) in 2007 and the Number of teachers of Rwanda in 2009?
Offer a terse response. 2.72e+06. What is the difference between the Number of teachers of Sub-Saharan Africa (developing only) in 2007 and the Number of teachers of Dominica in 2009?
Your answer should be very brief. 1.44e+06. What is the difference between the Number of teachers of Sub-Saharan Africa (developing only) in 2007 and the Number of teachers of Rwanda in 2009?
Your response must be concise. 1.43e+06. What is the difference between the Number of teachers of Dominica in 2007 and the Number of teachers of Rwanda in 2009?
Provide a succinct answer. -1.49e+04. What is the average Number of teachers of Latin America(developing only) per year?
Provide a short and direct response. 2.81e+06. What is the average Number of teachers in Sub-Saharan Africa (developing only) per year?
Offer a terse response. 1.25e+06. What is the average Number of teachers of Dominica per year?
Provide a short and direct response. 458.25. What is the average Number of teachers of Rwanda per year?
Your response must be concise. 8681.25. In the year 2001, what is the difference between the Number of teachers in Latin America(developing only) and Number of teachers in Sub-Saharan Africa (developing only)?
Give a very brief answer. 1.51e+06. In the year 2001, what is the difference between the Number of teachers in Latin America(developing only) and Number of teachers in Dominica?
Provide a short and direct response. 2.51e+06. In the year 2001, what is the difference between the Number of teachers of Latin America(developing only) and Number of teachers of Rwanda?
Your answer should be very brief. 2.50e+06. In the year 2001, what is the difference between the Number of teachers in Sub-Saharan Africa (developing only) and Number of teachers in Dominica?
Give a very brief answer. 1.00e+06. In the year 2001, what is the difference between the Number of teachers in Sub-Saharan Africa (developing only) and Number of teachers in Rwanda?
Keep it short and to the point. 9.97e+05. In the year 2001, what is the difference between the Number of teachers in Dominica and Number of teachers in Rwanda?
Provide a succinct answer. -5079. In the year 2002, what is the difference between the Number of teachers in Latin America(developing only) and Number of teachers in Sub-Saharan Africa (developing only)?
Offer a terse response. 1.66e+06. In the year 2002, what is the difference between the Number of teachers of Latin America(developing only) and Number of teachers of Dominica?
Your answer should be compact. 2.71e+06. In the year 2002, what is the difference between the Number of teachers of Latin America(developing only) and Number of teachers of Rwanda?
Your answer should be compact. 2.71e+06. In the year 2002, what is the difference between the Number of teachers in Sub-Saharan Africa (developing only) and Number of teachers in Dominica?
Ensure brevity in your answer.  1.05e+06. In the year 2002, what is the difference between the Number of teachers in Sub-Saharan Africa (developing only) and Number of teachers in Rwanda?
Offer a very short reply. 1.05e+06. In the year 2002, what is the difference between the Number of teachers in Dominica and Number of teachers in Rwanda?
Offer a terse response. -5886. In the year 2003, what is the difference between the Number of teachers of Latin America(developing only) and Number of teachers of Sub-Saharan Africa (developing only)?
Ensure brevity in your answer.  1.72e+06. In the year 2003, what is the difference between the Number of teachers in Latin America(developing only) and Number of teachers in Dominica?
Provide a succinct answer. 2.82e+06. In the year 2003, what is the difference between the Number of teachers of Latin America(developing only) and Number of teachers of Rwanda?
Your answer should be very brief. 2.82e+06. In the year 2003, what is the difference between the Number of teachers of Sub-Saharan Africa (developing only) and Number of teachers of Dominica?
Provide a short and direct response. 1.10e+06. In the year 2003, what is the difference between the Number of teachers of Sub-Saharan Africa (developing only) and Number of teachers of Rwanda?
Your answer should be compact. 1.10e+06. In the year 2003, what is the difference between the Number of teachers in Dominica and Number of teachers in Rwanda?
Your answer should be compact. -6598. In the year 2004, what is the difference between the Number of teachers in Latin America(developing only) and Number of teachers in Sub-Saharan Africa (developing only)?
Ensure brevity in your answer.  1.76e+06. In the year 2004, what is the difference between the Number of teachers in Latin America(developing only) and Number of teachers in Dominica?
Provide a succinct answer. 2.92e+06. In the year 2004, what is the difference between the Number of teachers in Latin America(developing only) and Number of teachers in Rwanda?
Your answer should be very brief. 2.91e+06. In the year 2004, what is the difference between the Number of teachers in Sub-Saharan Africa (developing only) and Number of teachers in Dominica?
Provide a succinct answer. 1.16e+06. In the year 2004, what is the difference between the Number of teachers in Sub-Saharan Africa (developing only) and Number of teachers in Rwanda?
Give a very brief answer. 1.15e+06. In the year 2004, what is the difference between the Number of teachers in Dominica and Number of teachers in Rwanda?
Offer a very short reply. -7305. In the year 2005, what is the difference between the Number of teachers of Latin America(developing only) and Number of teachers of Sub-Saharan Africa (developing only)?
Keep it short and to the point. 1.78e+06. In the year 2005, what is the difference between the Number of teachers in Latin America(developing only) and Number of teachers in Dominica?
Ensure brevity in your answer.  2.99e+06. In the year 2005, what is the difference between the Number of teachers of Latin America(developing only) and Number of teachers of Rwanda?
Provide a short and direct response. 2.99e+06. In the year 2005, what is the difference between the Number of teachers of Sub-Saharan Africa (developing only) and Number of teachers of Dominica?
Your answer should be very brief. 1.22e+06. In the year 2005, what is the difference between the Number of teachers in Sub-Saharan Africa (developing only) and Number of teachers in Rwanda?
Keep it short and to the point. 1.21e+06. In the year 2005, what is the difference between the Number of teachers in Dominica and Number of teachers in Rwanda?
Offer a very short reply. -7114. In the year 2006, what is the difference between the Number of teachers in Latin America(developing only) and Number of teachers in Sub-Saharan Africa (developing only)?
Your response must be concise. 1.51e+06. In the year 2006, what is the difference between the Number of teachers in Latin America(developing only) and Number of teachers in Dominica?
Your response must be concise. 2.85e+06. In the year 2006, what is the difference between the Number of teachers of Latin America(developing only) and Number of teachers of Rwanda?
Ensure brevity in your answer.  2.84e+06. In the year 2006, what is the difference between the Number of teachers in Sub-Saharan Africa (developing only) and Number of teachers in Dominica?
Offer a very short reply. 1.33e+06. In the year 2006, what is the difference between the Number of teachers in Sub-Saharan Africa (developing only) and Number of teachers in Rwanda?
Your response must be concise. 1.32e+06. In the year 2006, what is the difference between the Number of teachers in Dominica and Number of teachers in Rwanda?
Make the answer very short. -7363. In the year 2007, what is the difference between the Number of teachers of Latin America(developing only) and Number of teachers of Sub-Saharan Africa (developing only)?
Keep it short and to the point. 1.29e+06. In the year 2007, what is the difference between the Number of teachers in Latin America(developing only) and Number of teachers in Dominica?
Provide a succinct answer. 2.73e+06. In the year 2007, what is the difference between the Number of teachers of Latin America(developing only) and Number of teachers of Rwanda?
Keep it short and to the point. 2.72e+06. In the year 2007, what is the difference between the Number of teachers in Sub-Saharan Africa (developing only) and Number of teachers in Dominica?
Provide a short and direct response. 1.44e+06. In the year 2007, what is the difference between the Number of teachers in Sub-Saharan Africa (developing only) and Number of teachers in Rwanda?
Keep it short and to the point. 1.43e+06. In the year 2007, what is the difference between the Number of teachers of Dominica and Number of teachers of Rwanda?
Provide a succinct answer. -1.16e+04. In the year 2009, what is the difference between the Number of teachers of Latin America(developing only) and Number of teachers of Sub-Saharan Africa (developing only)?
Offer a terse response. 1.18e+06. In the year 2009, what is the difference between the Number of teachers of Latin America(developing only) and Number of teachers of Dominica?
Make the answer very short. 2.91e+06. In the year 2009, what is the difference between the Number of teachers of Latin America(developing only) and Number of teachers of Rwanda?
Offer a very short reply. 2.89e+06. In the year 2009, what is the difference between the Number of teachers of Sub-Saharan Africa (developing only) and Number of teachers of Dominica?
Your answer should be very brief. 1.72e+06. In the year 2009, what is the difference between the Number of teachers in Sub-Saharan Africa (developing only) and Number of teachers in Rwanda?
Offer a very short reply. 1.71e+06. In the year 2009, what is the difference between the Number of teachers in Dominica and Number of teachers in Rwanda?
Make the answer very short. -1.48e+04. What is the ratio of the Number of teachers of Latin America(developing only) in 2001 to that in 2002?
Your answer should be very brief. 0.92. What is the ratio of the Number of teachers in Sub-Saharan Africa (developing only) in 2001 to that in 2002?
Provide a succinct answer. 0.95. What is the ratio of the Number of teachers of Dominica in 2001 to that in 2002?
Keep it short and to the point. 0.84. What is the ratio of the Number of teachers of Rwanda in 2001 to that in 2002?
Ensure brevity in your answer.  0.86. What is the ratio of the Number of teachers of Latin America(developing only) in 2001 to that in 2003?
Give a very brief answer. 0.89. What is the ratio of the Number of teachers in Sub-Saharan Africa (developing only) in 2001 to that in 2003?
Provide a short and direct response. 0.91. What is the ratio of the Number of teachers in Dominica in 2001 to that in 2003?
Your answer should be very brief. 0.81. What is the ratio of the Number of teachers of Rwanda in 2001 to that in 2003?
Keep it short and to the point. 0.77. What is the ratio of the Number of teachers of Latin America(developing only) in 2001 to that in 2004?
Give a very brief answer. 0.86. What is the ratio of the Number of teachers of Sub-Saharan Africa (developing only) in 2001 to that in 2004?
Your answer should be very brief. 0.86. What is the ratio of the Number of teachers in Dominica in 2001 to that in 2004?
Your answer should be very brief. 0.84. What is the ratio of the Number of teachers in Rwanda in 2001 to that in 2004?
Make the answer very short. 0.7. What is the ratio of the Number of teachers of Latin America(developing only) in 2001 to that in 2005?
Offer a very short reply. 0.84. What is the ratio of the Number of teachers in Sub-Saharan Africa (developing only) in 2001 to that in 2005?
Offer a terse response. 0.82. What is the ratio of the Number of teachers in Dominica in 2001 to that in 2005?
Ensure brevity in your answer.  0.75. What is the ratio of the Number of teachers of Rwanda in 2001 to that in 2005?
Your answer should be very brief. 0.72. What is the ratio of the Number of teachers in Latin America(developing only) in 2001 to that in 2006?
Your answer should be very brief. 0.88. What is the ratio of the Number of teachers of Sub-Saharan Africa (developing only) in 2001 to that in 2006?
Offer a very short reply. 0.75. What is the ratio of the Number of teachers in Dominica in 2001 to that in 2006?
Keep it short and to the point. 0.82. What is the ratio of the Number of teachers of Rwanda in 2001 to that in 2006?
Your answer should be compact. 0.7. What is the ratio of the Number of teachers in Latin America(developing only) in 2001 to that in 2007?
Keep it short and to the point. 0.92. What is the ratio of the Number of teachers of Sub-Saharan Africa (developing only) in 2001 to that in 2007?
Your answer should be very brief. 0.69. What is the ratio of the Number of teachers in Dominica in 2001 to that in 2007?
Keep it short and to the point. 0.8. What is the ratio of the Number of teachers in Rwanda in 2001 to that in 2007?
Provide a short and direct response. 0.45. What is the ratio of the Number of teachers of Latin America(developing only) in 2001 to that in 2009?
Provide a short and direct response. 0.86. What is the ratio of the Number of teachers of Sub-Saharan Africa (developing only) in 2001 to that in 2009?
Provide a succinct answer. 0.58. What is the ratio of the Number of teachers of Dominica in 2001 to that in 2009?
Offer a very short reply. 0.71. What is the ratio of the Number of teachers of Rwanda in 2001 to that in 2009?
Your answer should be very brief. 0.36. What is the ratio of the Number of teachers in Latin America(developing only) in 2002 to that in 2003?
Ensure brevity in your answer.  0.96. What is the ratio of the Number of teachers in Sub-Saharan Africa (developing only) in 2002 to that in 2003?
Provide a short and direct response. 0.95. What is the ratio of the Number of teachers of Rwanda in 2002 to that in 2003?
Ensure brevity in your answer.  0.9. What is the ratio of the Number of teachers of Latin America(developing only) in 2002 to that in 2004?
Your response must be concise. 0.93. What is the ratio of the Number of teachers of Sub-Saharan Africa (developing only) in 2002 to that in 2004?
Offer a very short reply. 0.91. What is the ratio of the Number of teachers of Rwanda in 2002 to that in 2004?
Make the answer very short. 0.82. What is the ratio of the Number of teachers in Latin America(developing only) in 2002 to that in 2005?
Provide a succinct answer. 0.91. What is the ratio of the Number of teachers in Sub-Saharan Africa (developing only) in 2002 to that in 2005?
Give a very brief answer. 0.87. What is the ratio of the Number of teachers in Dominica in 2002 to that in 2005?
Ensure brevity in your answer.  0.89. What is the ratio of the Number of teachers in Rwanda in 2002 to that in 2005?
Offer a terse response. 0.83. What is the ratio of the Number of teachers in Latin America(developing only) in 2002 to that in 2006?
Offer a very short reply. 0.95. What is the ratio of the Number of teachers in Sub-Saharan Africa (developing only) in 2002 to that in 2006?
Give a very brief answer. 0.79. What is the ratio of the Number of teachers in Dominica in 2002 to that in 2006?
Offer a very short reply. 0.97. What is the ratio of the Number of teachers in Rwanda in 2002 to that in 2006?
Keep it short and to the point. 0.81. What is the ratio of the Number of teachers of Sub-Saharan Africa (developing only) in 2002 to that in 2007?
Give a very brief answer. 0.73. What is the ratio of the Number of teachers in Dominica in 2002 to that in 2007?
Make the answer very short. 0.94. What is the ratio of the Number of teachers in Rwanda in 2002 to that in 2007?
Keep it short and to the point. 0.52. What is the ratio of the Number of teachers in Latin America(developing only) in 2002 to that in 2009?
Make the answer very short. 0.93. What is the ratio of the Number of teachers in Sub-Saharan Africa (developing only) in 2002 to that in 2009?
Provide a succinct answer. 0.61. What is the ratio of the Number of teachers of Dominica in 2002 to that in 2009?
Ensure brevity in your answer.  0.85. What is the ratio of the Number of teachers in Rwanda in 2002 to that in 2009?
Your answer should be very brief. 0.41. What is the ratio of the Number of teachers of Latin America(developing only) in 2003 to that in 2004?
Provide a short and direct response. 0.97. What is the ratio of the Number of teachers in Sub-Saharan Africa (developing only) in 2003 to that in 2004?
Provide a succinct answer. 0.95. What is the ratio of the Number of teachers in Dominica in 2003 to that in 2004?
Your answer should be very brief. 1.03. What is the ratio of the Number of teachers of Rwanda in 2003 to that in 2004?
Make the answer very short. 0.91. What is the ratio of the Number of teachers in Latin America(developing only) in 2003 to that in 2005?
Your response must be concise. 0.94. What is the ratio of the Number of teachers in Sub-Saharan Africa (developing only) in 2003 to that in 2005?
Keep it short and to the point. 0.91. What is the ratio of the Number of teachers of Dominica in 2003 to that in 2005?
Offer a terse response. 0.93. What is the ratio of the Number of teachers of Rwanda in 2003 to that in 2005?
Offer a terse response. 0.93. What is the ratio of the Number of teachers in Latin America(developing only) in 2003 to that in 2006?
Offer a terse response. 0.99. What is the ratio of the Number of teachers of Sub-Saharan Africa (developing only) in 2003 to that in 2006?
Make the answer very short. 0.83. What is the ratio of the Number of teachers of Dominica in 2003 to that in 2006?
Provide a short and direct response. 1.01. What is the ratio of the Number of teachers in Rwanda in 2003 to that in 2006?
Give a very brief answer. 0.9. What is the ratio of the Number of teachers in Latin America(developing only) in 2003 to that in 2007?
Your answer should be very brief. 1.03. What is the ratio of the Number of teachers of Sub-Saharan Africa (developing only) in 2003 to that in 2007?
Your answer should be compact. 0.76. What is the ratio of the Number of teachers in Dominica in 2003 to that in 2007?
Ensure brevity in your answer.  0.98. What is the ratio of the Number of teachers of Rwanda in 2003 to that in 2007?
Ensure brevity in your answer.  0.58. What is the ratio of the Number of teachers of Latin America(developing only) in 2003 to that in 2009?
Your answer should be very brief. 0.97. What is the ratio of the Number of teachers of Sub-Saharan Africa (developing only) in 2003 to that in 2009?
Your answer should be compact. 0.64. What is the ratio of the Number of teachers in Dominica in 2003 to that in 2009?
Your answer should be compact. 0.88. What is the ratio of the Number of teachers of Rwanda in 2003 to that in 2009?
Your response must be concise. 0.46. What is the ratio of the Number of teachers in Latin America(developing only) in 2004 to that in 2005?
Ensure brevity in your answer.  0.97. What is the ratio of the Number of teachers in Sub-Saharan Africa (developing only) in 2004 to that in 2005?
Your response must be concise. 0.95. What is the ratio of the Number of teachers of Dominica in 2004 to that in 2005?
Your answer should be very brief. 0.9. What is the ratio of the Number of teachers of Rwanda in 2004 to that in 2005?
Your answer should be compact. 1.02. What is the ratio of the Number of teachers of Latin America(developing only) in 2004 to that in 2006?
Make the answer very short. 1.02. What is the ratio of the Number of teachers in Sub-Saharan Africa (developing only) in 2004 to that in 2006?
Your answer should be compact. 0.87. What is the ratio of the Number of teachers in Rwanda in 2004 to that in 2006?
Your answer should be compact. 0.99. What is the ratio of the Number of teachers of Latin America(developing only) in 2004 to that in 2007?
Provide a succinct answer. 1.07. What is the ratio of the Number of teachers of Sub-Saharan Africa (developing only) in 2004 to that in 2007?
Your answer should be compact. 0.8. What is the ratio of the Number of teachers of Dominica in 2004 to that in 2007?
Ensure brevity in your answer.  0.95. What is the ratio of the Number of teachers of Rwanda in 2004 to that in 2007?
Make the answer very short. 0.64. What is the ratio of the Number of teachers of Latin America(developing only) in 2004 to that in 2009?
Provide a succinct answer. 1. What is the ratio of the Number of teachers of Sub-Saharan Africa (developing only) in 2004 to that in 2009?
Keep it short and to the point. 0.67. What is the ratio of the Number of teachers in Dominica in 2004 to that in 2009?
Provide a short and direct response. 0.85. What is the ratio of the Number of teachers of Rwanda in 2004 to that in 2009?
Your answer should be compact. 0.51. What is the ratio of the Number of teachers in Latin America(developing only) in 2005 to that in 2006?
Your answer should be compact. 1.05. What is the ratio of the Number of teachers of Sub-Saharan Africa (developing only) in 2005 to that in 2006?
Give a very brief answer. 0.91. What is the ratio of the Number of teachers in Dominica in 2005 to that in 2006?
Offer a terse response. 1.09. What is the ratio of the Number of teachers of Rwanda in 2005 to that in 2006?
Provide a succinct answer. 0.97. What is the ratio of the Number of teachers in Latin America(developing only) in 2005 to that in 2007?
Give a very brief answer. 1.09. What is the ratio of the Number of teachers in Sub-Saharan Africa (developing only) in 2005 to that in 2007?
Your answer should be very brief. 0.84. What is the ratio of the Number of teachers of Dominica in 2005 to that in 2007?
Make the answer very short. 1.06. What is the ratio of the Number of teachers in Rwanda in 2005 to that in 2007?
Ensure brevity in your answer.  0.63. What is the ratio of the Number of teachers of Latin America(developing only) in 2005 to that in 2009?
Offer a terse response. 1.03. What is the ratio of the Number of teachers of Sub-Saharan Africa (developing only) in 2005 to that in 2009?
Your answer should be compact. 0.71. What is the ratio of the Number of teachers in Dominica in 2005 to that in 2009?
Offer a terse response. 0.95. What is the ratio of the Number of teachers in Rwanda in 2005 to that in 2009?
Your response must be concise. 0.5. What is the ratio of the Number of teachers in Latin America(developing only) in 2006 to that in 2007?
Your response must be concise. 1.04. What is the ratio of the Number of teachers in Sub-Saharan Africa (developing only) in 2006 to that in 2007?
Your answer should be compact. 0.92. What is the ratio of the Number of teachers of Dominica in 2006 to that in 2007?
Your answer should be very brief. 0.97. What is the ratio of the Number of teachers of Rwanda in 2006 to that in 2007?
Your answer should be very brief. 0.65. What is the ratio of the Number of teachers in Latin America(developing only) in 2006 to that in 2009?
Ensure brevity in your answer.  0.98. What is the ratio of the Number of teachers of Sub-Saharan Africa (developing only) in 2006 to that in 2009?
Give a very brief answer. 0.77. What is the ratio of the Number of teachers of Dominica in 2006 to that in 2009?
Give a very brief answer. 0.87. What is the ratio of the Number of teachers of Rwanda in 2006 to that in 2009?
Your answer should be very brief. 0.51. What is the ratio of the Number of teachers of Latin America(developing only) in 2007 to that in 2009?
Offer a very short reply. 0.94. What is the ratio of the Number of teachers of Sub-Saharan Africa (developing only) in 2007 to that in 2009?
Make the answer very short. 0.84. What is the ratio of the Number of teachers of Dominica in 2007 to that in 2009?
Offer a terse response. 0.9. What is the ratio of the Number of teachers in Rwanda in 2007 to that in 2009?
Keep it short and to the point. 0.79. What is the difference between the highest and the second highest Number of teachers of Latin America(developing only)?
Give a very brief answer. 7.62e+04. What is the difference between the highest and the second highest Number of teachers of Sub-Saharan Africa (developing only)?
Keep it short and to the point. 2.78e+05. What is the difference between the highest and the second highest Number of teachers of Dominica?
Your answer should be compact. 28. What is the difference between the highest and the second highest Number of teachers in Rwanda?
Your answer should be compact. 3226. What is the difference between the highest and the lowest Number of teachers of Latin America(developing only)?
Keep it short and to the point. 4.83e+05. What is the difference between the highest and the lowest Number of teachers in Sub-Saharan Africa (developing only)?
Ensure brevity in your answer.  7.20e+05. What is the difference between the highest and the lowest Number of teachers of Dominica?
Your response must be concise. 150. What is the difference between the highest and the lowest Number of teachers in Rwanda?
Offer a terse response. 9876. 